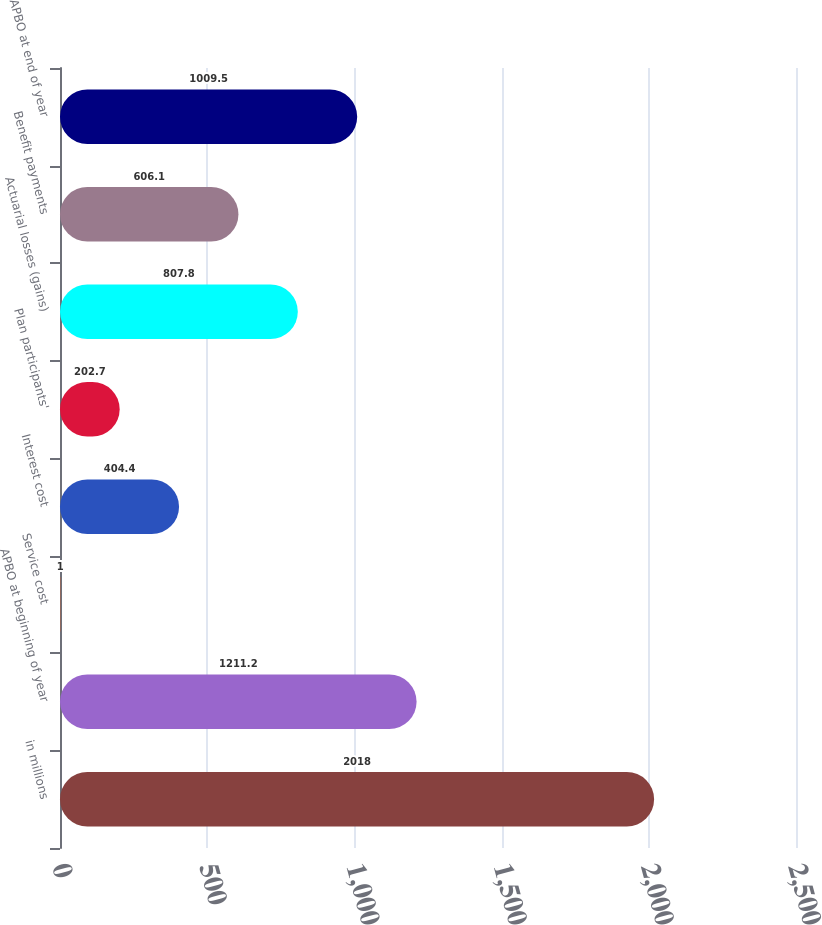Convert chart to OTSL. <chart><loc_0><loc_0><loc_500><loc_500><bar_chart><fcel>in millions<fcel>APBO at beginning of year<fcel>Service cost<fcel>Interest cost<fcel>Plan participants'<fcel>Actuarial losses (gains)<fcel>Benefit payments<fcel>APBO at end of year<nl><fcel>2018<fcel>1211.2<fcel>1<fcel>404.4<fcel>202.7<fcel>807.8<fcel>606.1<fcel>1009.5<nl></chart> 